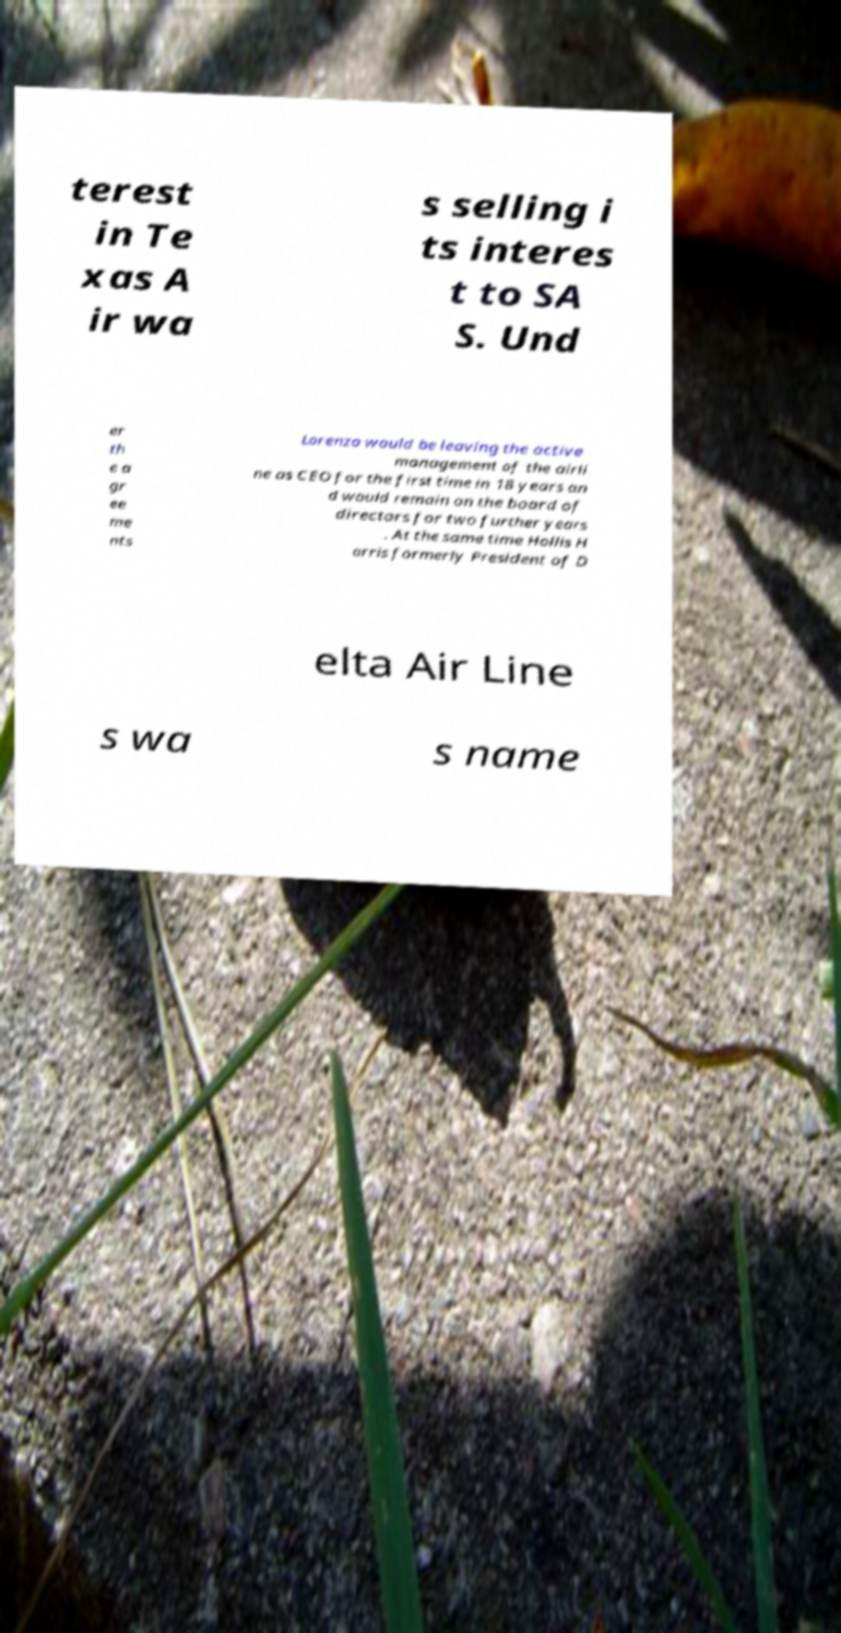I need the written content from this picture converted into text. Can you do that? terest in Te xas A ir wa s selling i ts interes t to SA S. Und er th e a gr ee me nts Lorenzo would be leaving the active management of the airli ne as CEO for the first time in 18 years an d would remain on the board of directors for two further years . At the same time Hollis H arris formerly President of D elta Air Line s wa s name 